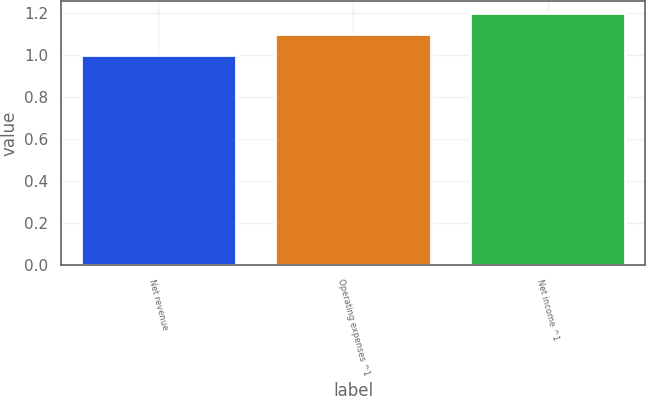Convert chart to OTSL. <chart><loc_0><loc_0><loc_500><loc_500><bar_chart><fcel>Net revenue<fcel>Operating expenses ^1<fcel>Net income ^1<nl><fcel>1<fcel>1.1<fcel>1.2<nl></chart> 